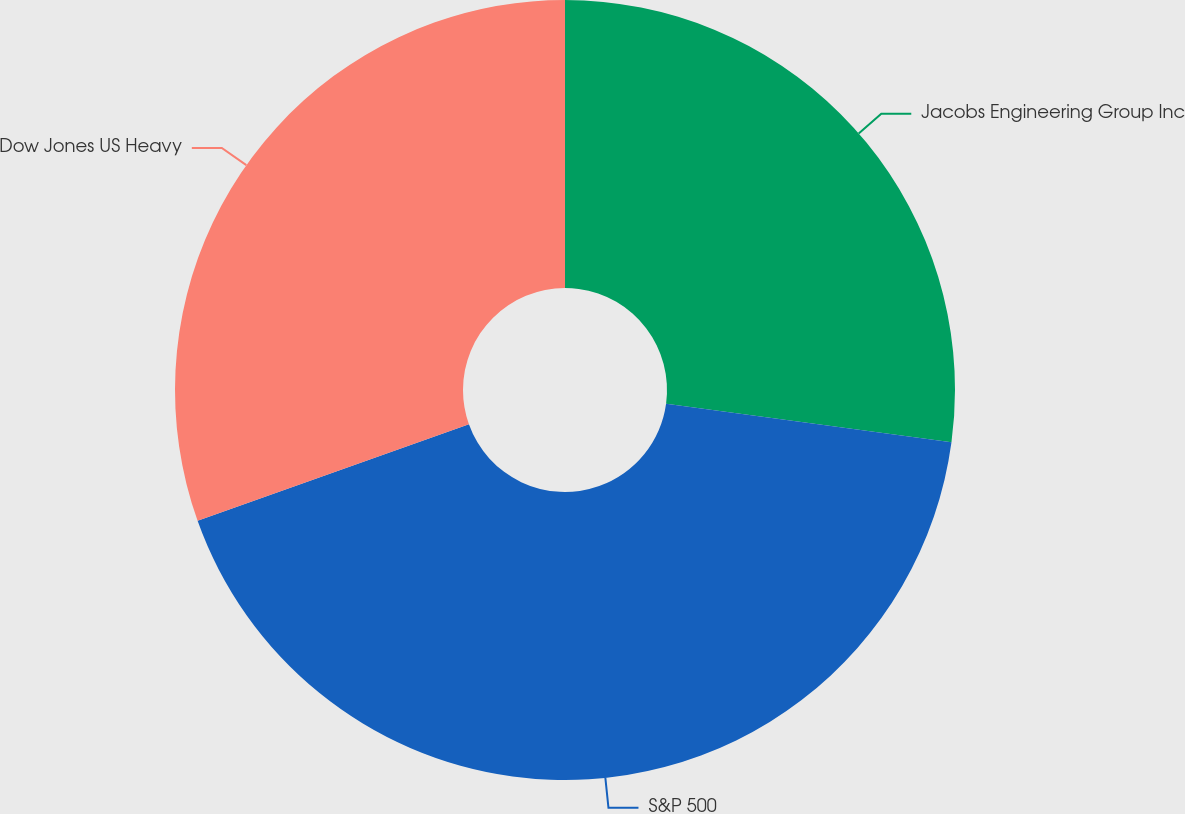Convert chart to OTSL. <chart><loc_0><loc_0><loc_500><loc_500><pie_chart><fcel>Jacobs Engineering Group Inc<fcel>S&P 500<fcel>Dow Jones US Heavy<nl><fcel>27.14%<fcel>42.41%<fcel>30.44%<nl></chart> 